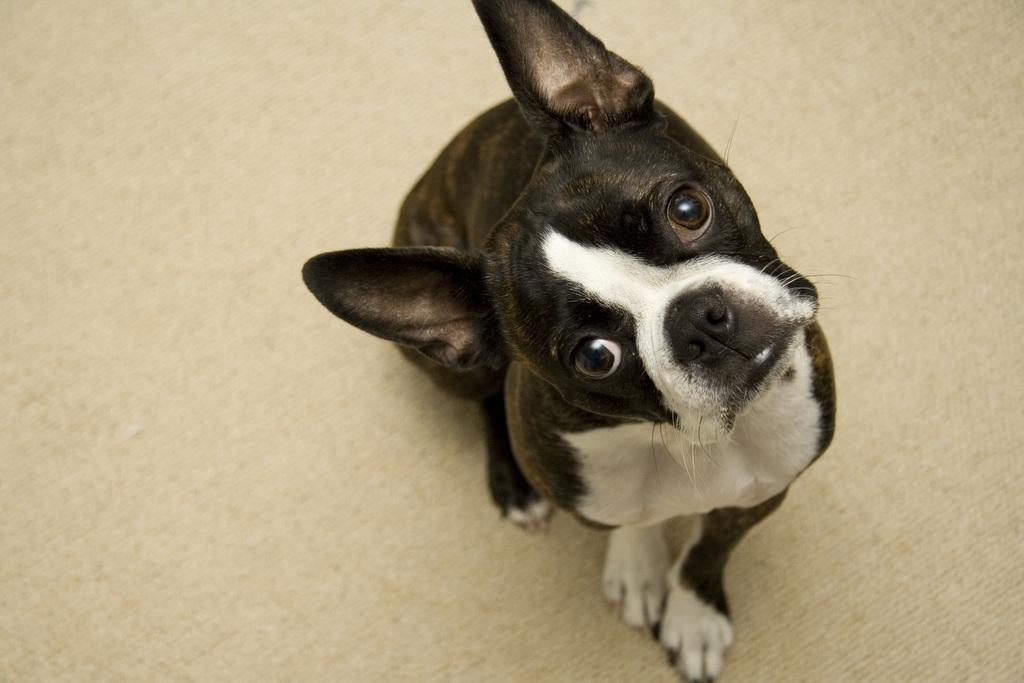What is the main subject in the foreground of the image? There is a dog in the foreground of the image. What type of surface is visible in the image? There is a floor visible in the image. What type of scarf is the dog wearing in the image? There is no scarf present in the image; the dog is not wearing any clothing. 